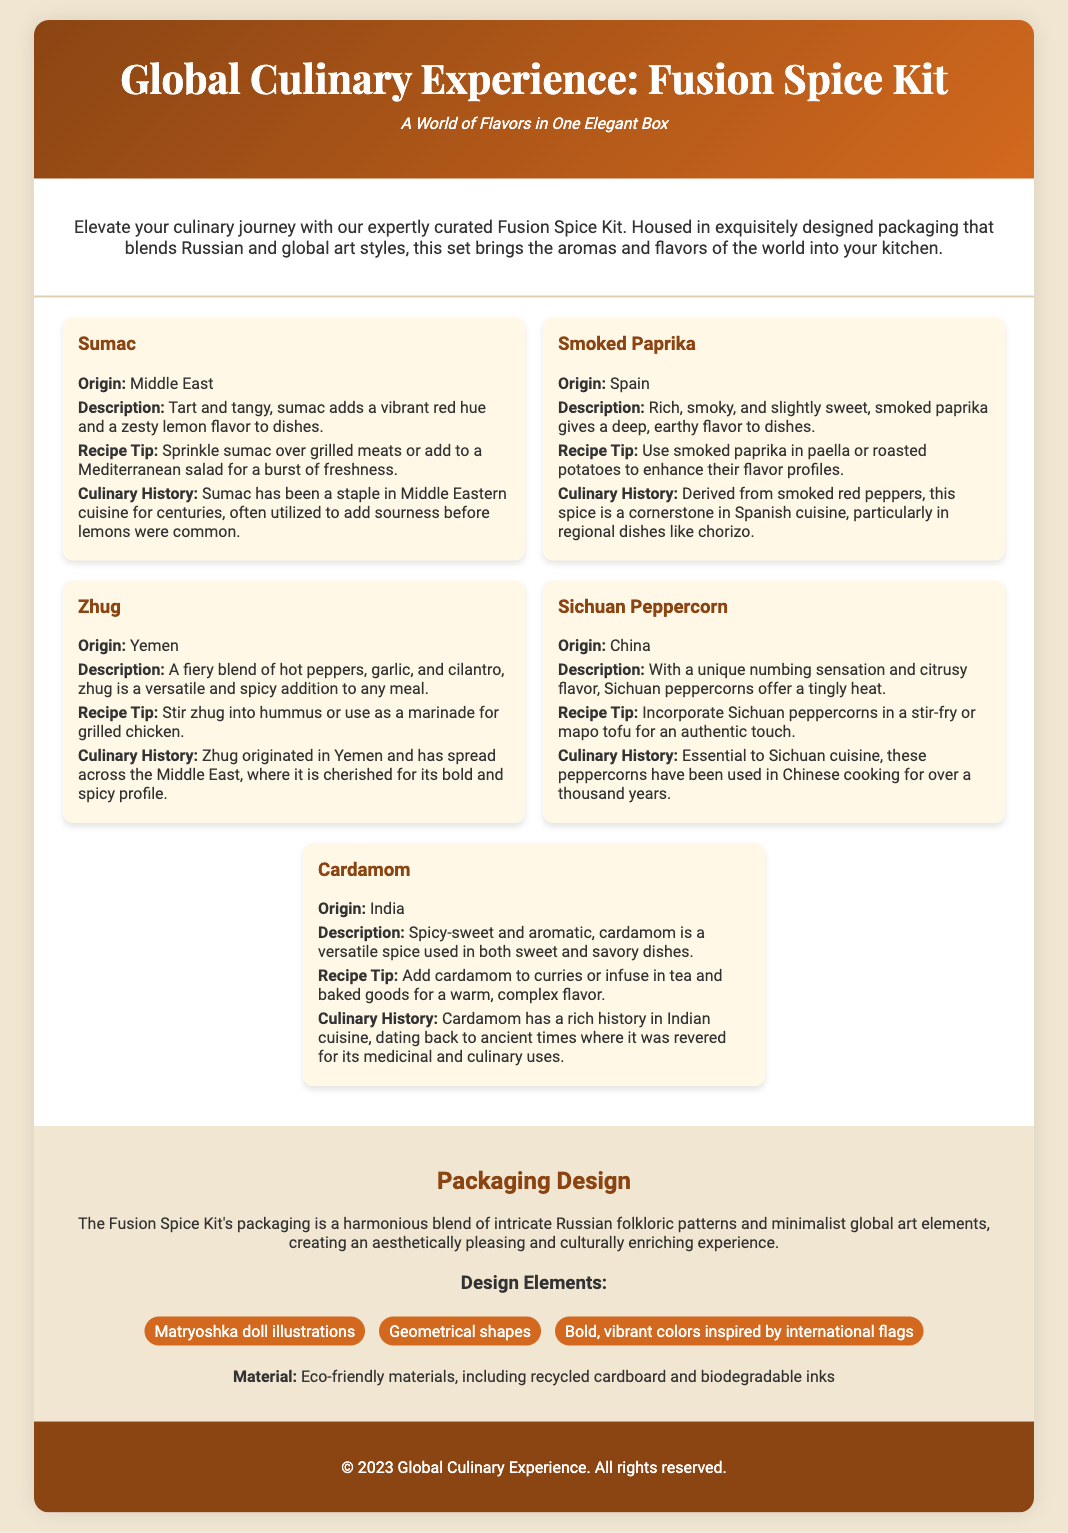What is the title of the product? The title of the product is prominently displayed at the top of the document as "Global Culinary Experience: Fusion Spice Kit."
Answer: Global Culinary Experience: Fusion Spice Kit How many spices are included in the kit? The document lists a total of five different spices included in the Fusion Spice Kit.
Answer: Five What is a unique feature of the packaging design? The packaging design is described as a blend of Russian folkloric patterns and minimalist global art elements, highlighting cultural richness.
Answer: A harmonious blend of intricate Russian folkloric patterns and minimalist global art elements What spice originates from China? The document provides specific origins for each spice, identifying Sichuan Peppercorn as the one that comes from China.
Answer: Sichuan Peppercorn Which spice has a tart and tangy flavor? The description of sumac highlights its tart and tangy flavor as a key characteristic.
Answer: Sumac What is the primary ingredient in zhug? The document states that zhug is a fiery blend, with hot peppers being a primary component of this spice.
Answer: Hot peppers What material is used for the packaging? The document specifies that the packaging is made from eco-friendly materials, including recycled cardboard.
Answer: Eco-friendly materials Name one culinary history detail about smoked paprika. The document mentions that smoked paprika is a cornerstone in Spanish cuisine, often used in regional dishes.
Answer: A cornerstone in Spanish cuisine What recipe tip is suggested for cardamom? The document recommends adding cardamom to curries or infusing it in tea and baked goods to enhance flavors.
Answer: Add to curries or infuse in tea and baked goods 